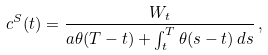<formula> <loc_0><loc_0><loc_500><loc_500>c ^ { S } ( t ) = \frac { W _ { t } } { a \theta ( T - t ) + \int _ { t } ^ { T } \theta ( s - t ) \, d s } \, ,</formula> 